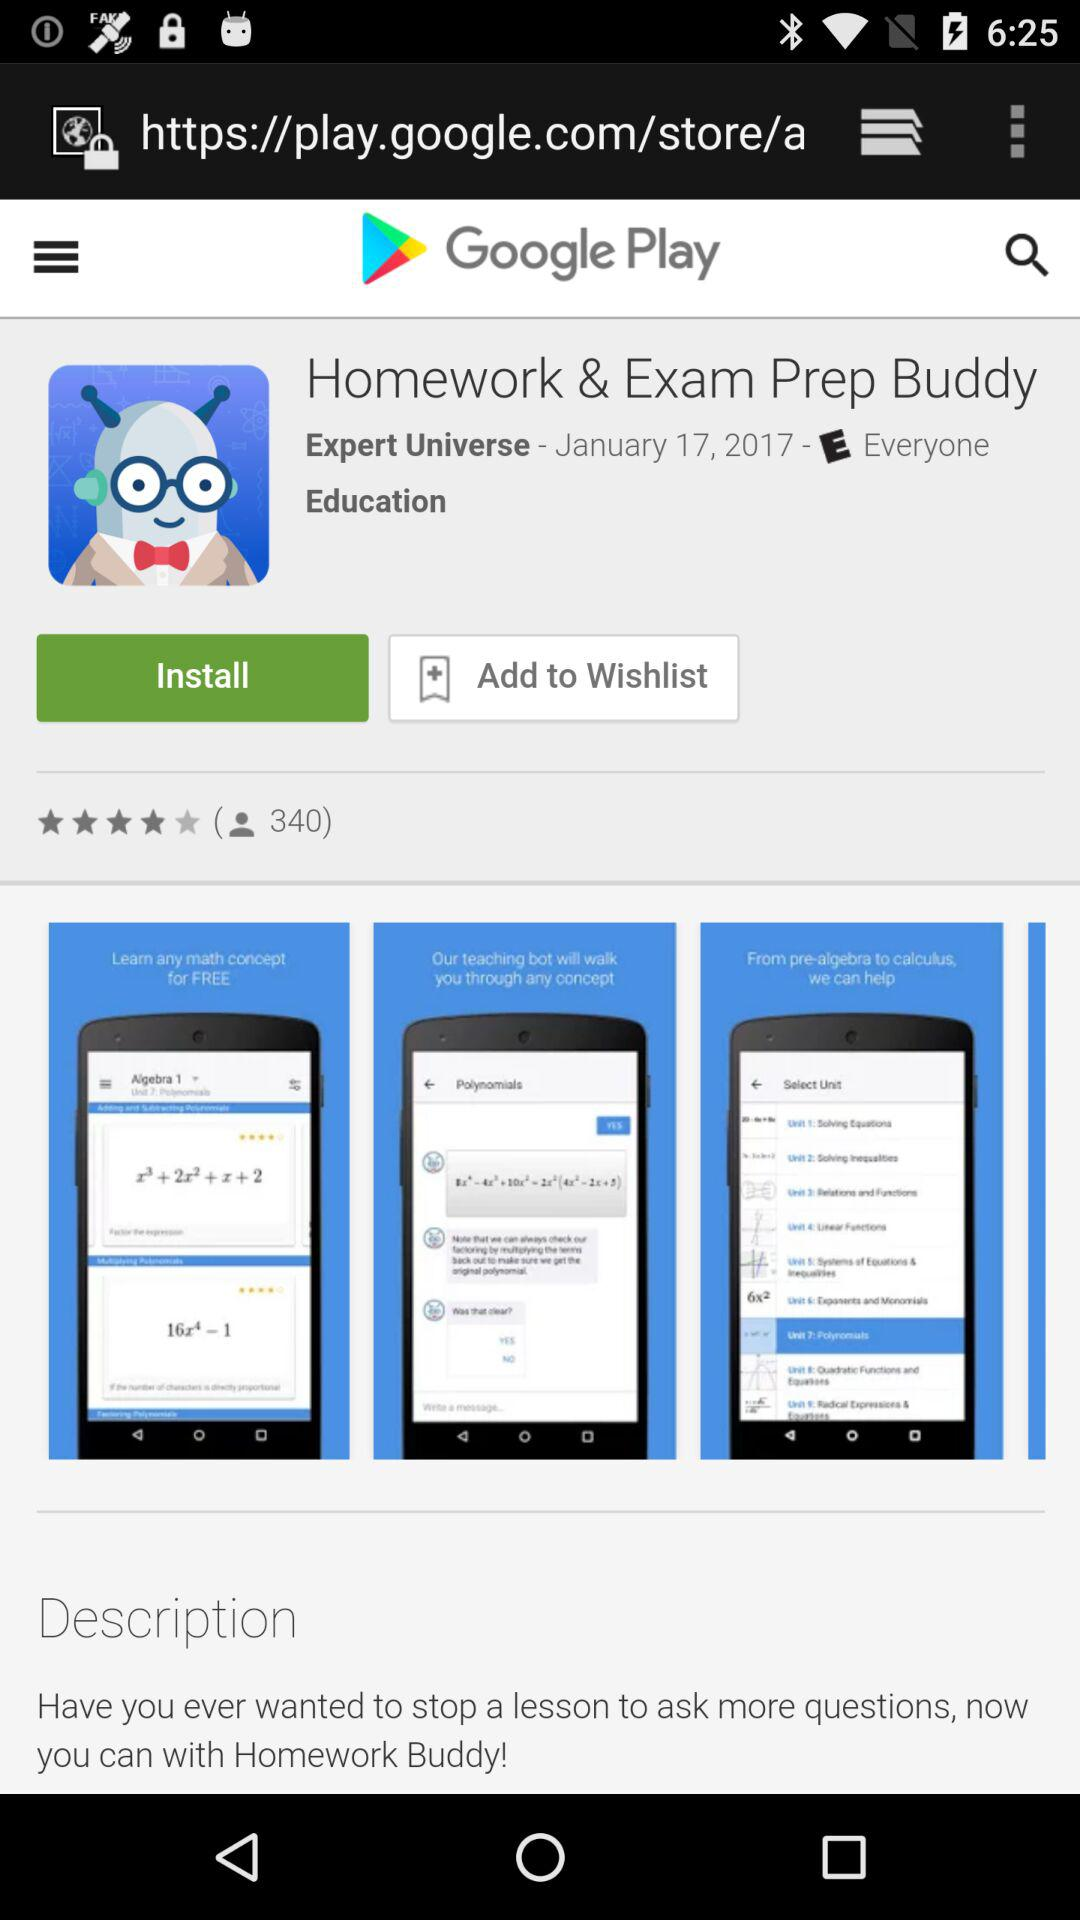How much does "Homework & Exam Prep Buddy" cost?
When the provided information is insufficient, respond with <no answer>. <no answer> 